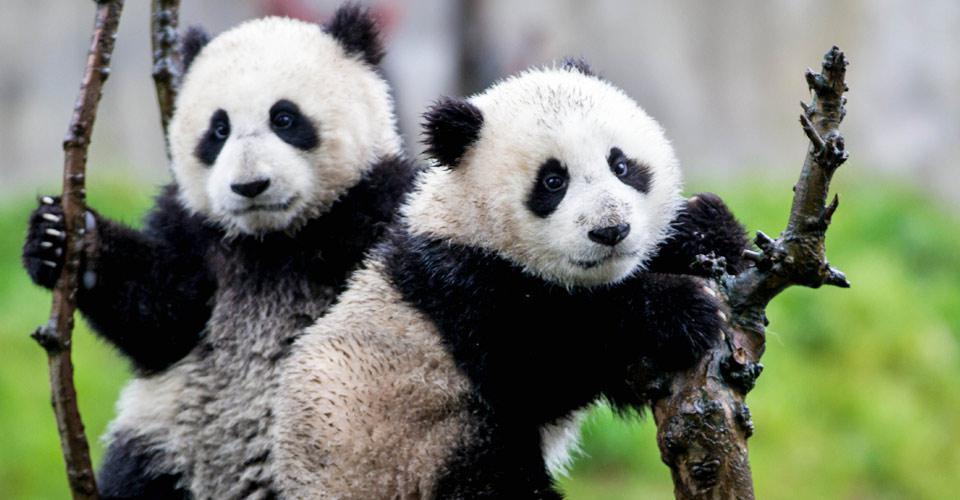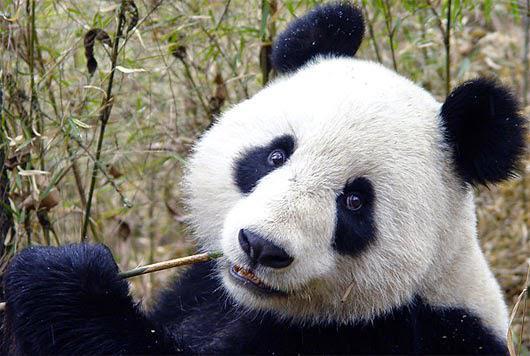The first image is the image on the left, the second image is the image on the right. Assess this claim about the two images: "There are no more than three panda bears.". Correct or not? Answer yes or no. Yes. The first image is the image on the left, the second image is the image on the right. For the images shown, is this caption "There are two pandas climbing a branch." true? Answer yes or no. Yes. 